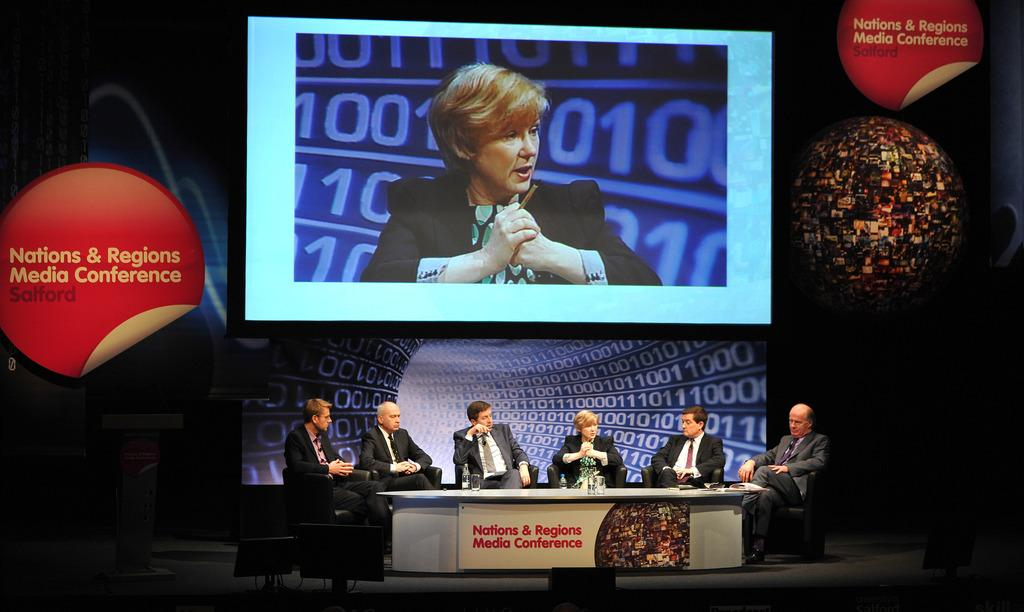<image>
Summarize the visual content of the image. Six people sut behind a desk deep in discussion below a large screen at the Nations & Regions Media Conference in Salford UK. 